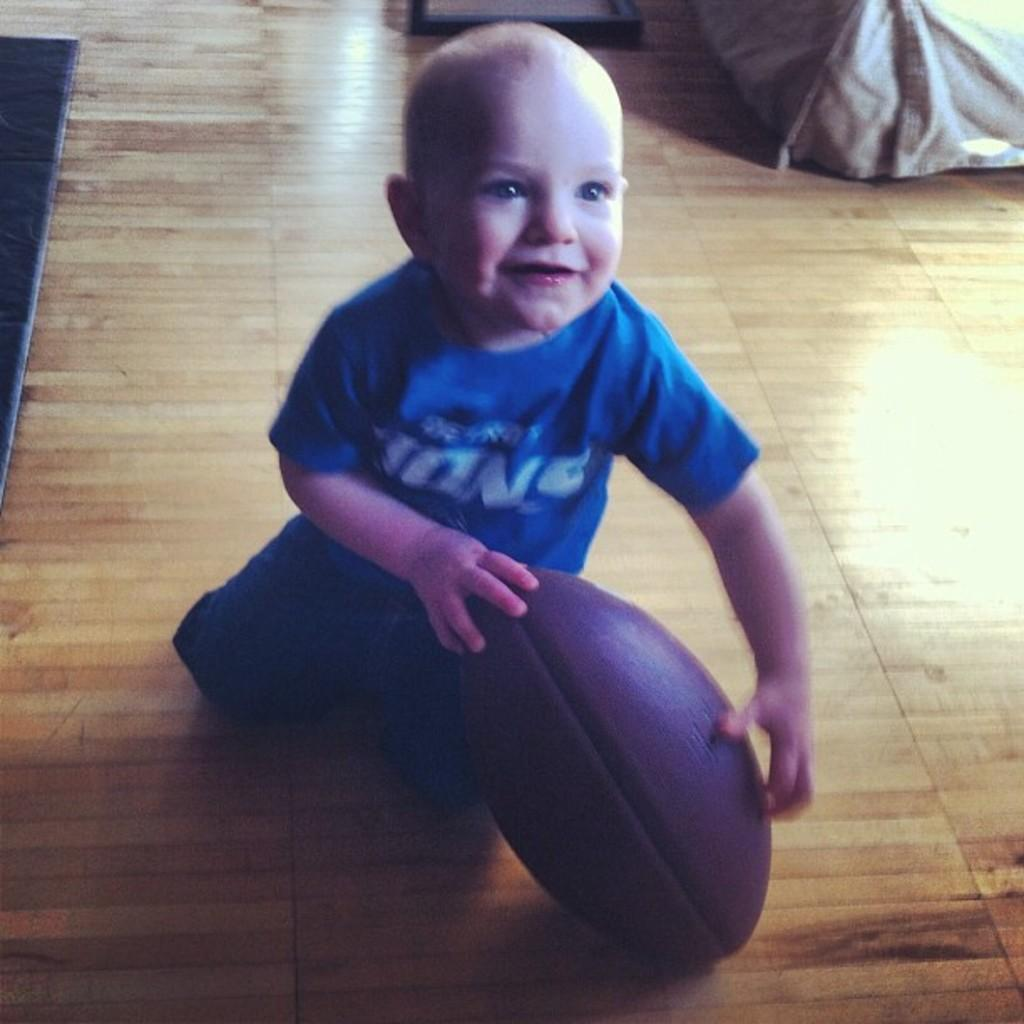What is the main subject of the image? There is a boy in the center of the image. What is the boy holding in the image? The boy is holding a ball. What type of flooring is visible at the bottom of the image? There is wooden flooring at the bottom of the image. What type of bird is perched on the boy's shoulder in the image? There is no bird present on the boy's shoulder in the image. 